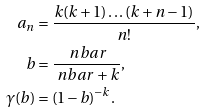Convert formula to latex. <formula><loc_0><loc_0><loc_500><loc_500>a _ { n } & = \frac { k ( k + 1 ) \dots ( k + n - 1 ) } { n ! } , \\ b & = \frac { \ n b a r } { \ n b a r + k } , \\ \gamma ( b ) & = ( 1 - b ) ^ { - k } .</formula> 